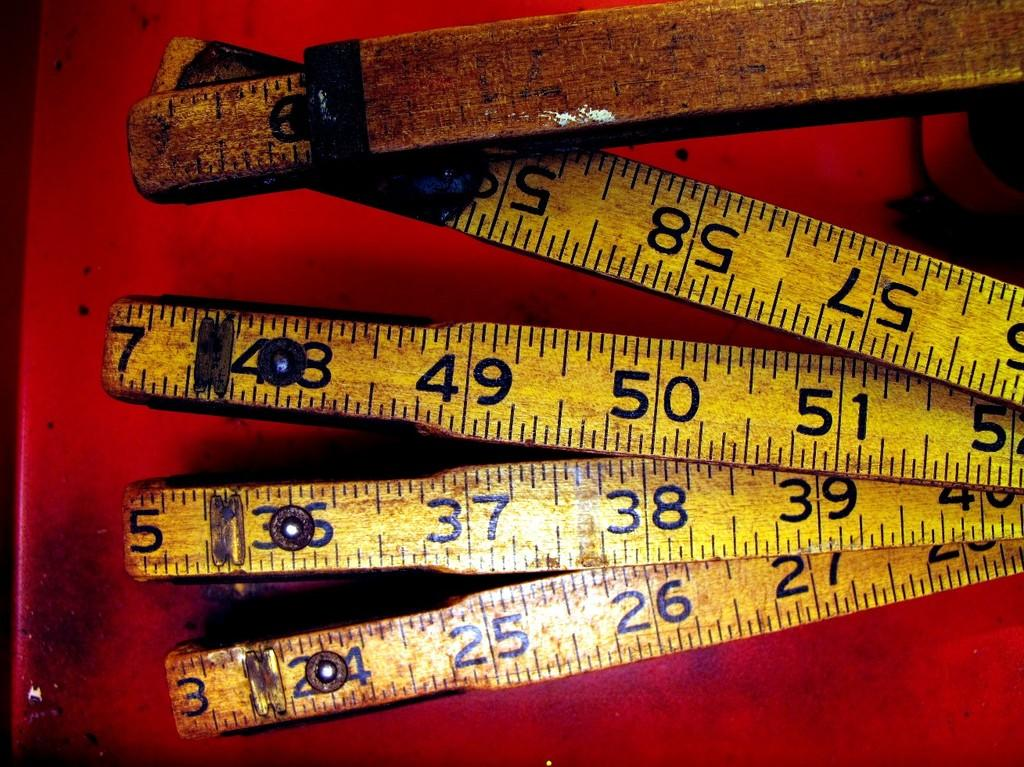<image>
Write a terse but informative summary of the picture. The middle most number on this measuring stick is 50 